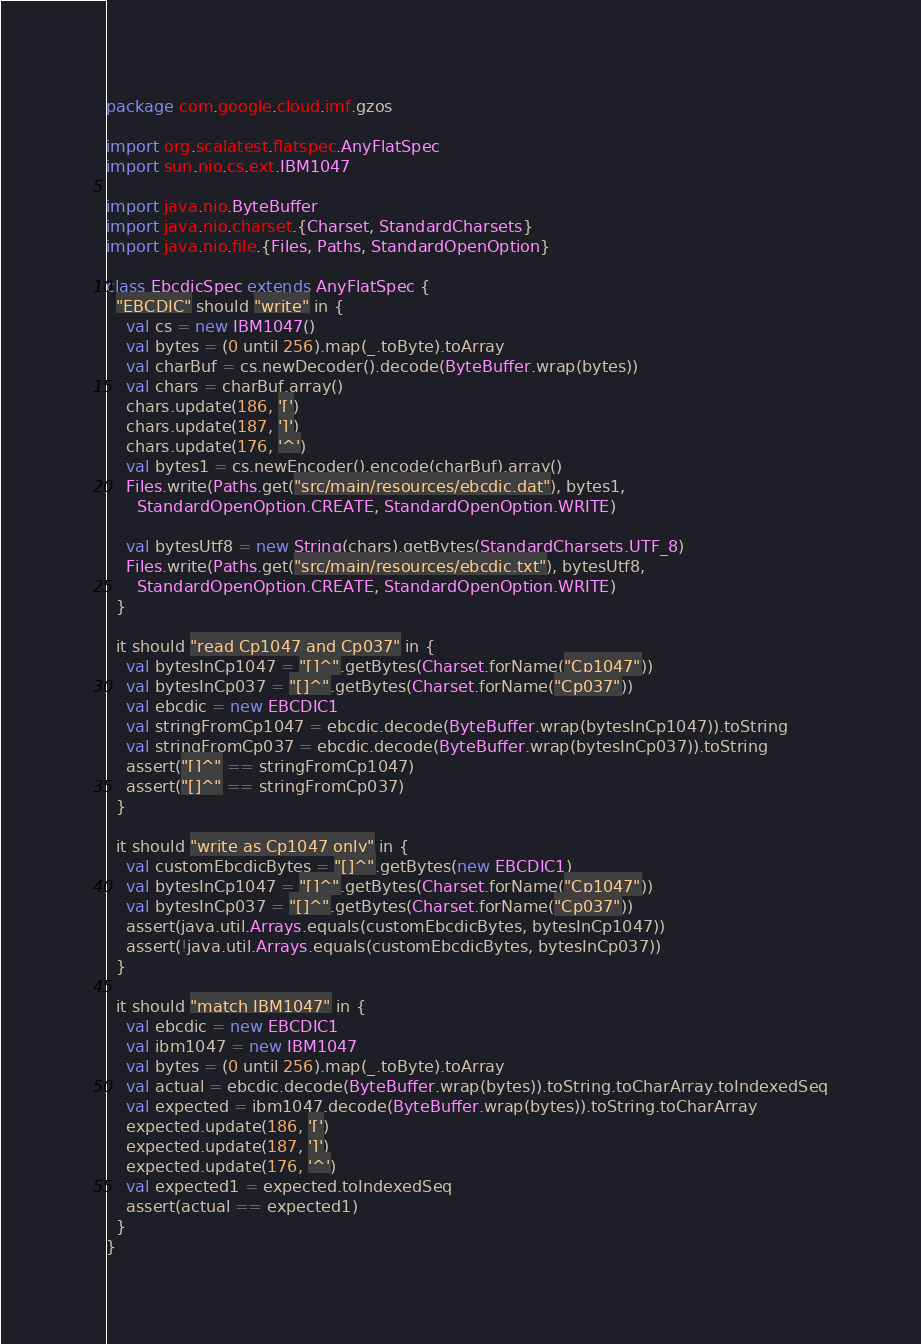Convert code to text. <code><loc_0><loc_0><loc_500><loc_500><_Scala_>package com.google.cloud.imf.gzos

import org.scalatest.flatspec.AnyFlatSpec
import sun.nio.cs.ext.IBM1047

import java.nio.ByteBuffer
import java.nio.charset.{Charset, StandardCharsets}
import java.nio.file.{Files, Paths, StandardOpenOption}

class EbcdicSpec extends AnyFlatSpec {
  "EBCDIC" should "write" in {
    val cs = new IBM1047()
    val bytes = (0 until 256).map(_.toByte).toArray
    val charBuf = cs.newDecoder().decode(ByteBuffer.wrap(bytes))
    val chars = charBuf.array()
    chars.update(186, '[')
    chars.update(187, ']')
    chars.update(176, '^')
    val bytes1 = cs.newEncoder().encode(charBuf).array()
    Files.write(Paths.get("src/main/resources/ebcdic.dat"), bytes1,
      StandardOpenOption.CREATE, StandardOpenOption.WRITE)

    val bytesUtf8 = new String(chars).getBytes(StandardCharsets.UTF_8)
    Files.write(Paths.get("src/main/resources/ebcdic.txt"), bytesUtf8,
      StandardOpenOption.CREATE, StandardOpenOption.WRITE)
  }

  it should "read Cp1047 and Cp037" in {
    val bytesInCp1047 = "[]^".getBytes(Charset.forName("Cp1047"))
    val bytesInCp037 = "[]^".getBytes(Charset.forName("Cp037"))
    val ebcdic = new EBCDIC1
    val stringFromCp1047 = ebcdic.decode(ByteBuffer.wrap(bytesInCp1047)).toString
    val stringFromCp037 = ebcdic.decode(ByteBuffer.wrap(bytesInCp037)).toString
    assert("[]^" == stringFromCp1047)
    assert("[]^" == stringFromCp037)
  }

  it should "write as Cp1047 only" in {
    val customEbcdicBytes = "[]^".getBytes(new EBCDIC1)
    val bytesInCp1047 = "[]^".getBytes(Charset.forName("Cp1047"))
    val bytesInCp037 = "[]^".getBytes(Charset.forName("Cp037"))
    assert(java.util.Arrays.equals(customEbcdicBytes, bytesInCp1047))
    assert(!java.util.Arrays.equals(customEbcdicBytes, bytesInCp037))
  }

  it should "match IBM1047" in {
    val ebcdic = new EBCDIC1
    val ibm1047 = new IBM1047
    val bytes = (0 until 256).map(_.toByte).toArray
    val actual = ebcdic.decode(ByteBuffer.wrap(bytes)).toString.toCharArray.toIndexedSeq
    val expected = ibm1047.decode(ByteBuffer.wrap(bytes)).toString.toCharArray
    expected.update(186, '[')
    expected.update(187, ']')
    expected.update(176, '^')
    val expected1 = expected.toIndexedSeq
    assert(actual == expected1)
  }
}
</code> 